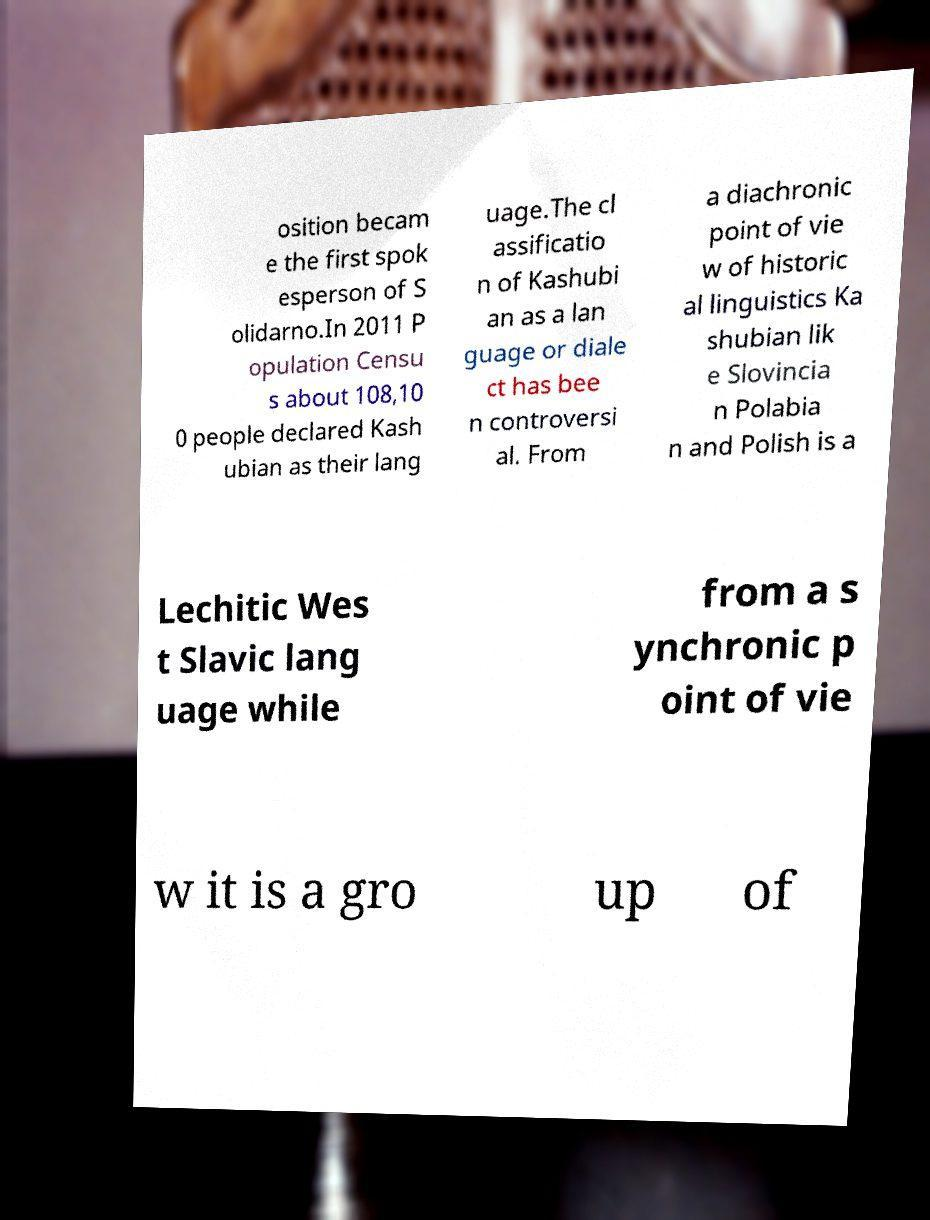Can you accurately transcribe the text from the provided image for me? osition becam e the first spok esperson of S olidarno.In 2011 P opulation Censu s about 108,10 0 people declared Kash ubian as their lang uage.The cl assificatio n of Kashubi an as a lan guage or diale ct has bee n controversi al. From a diachronic point of vie w of historic al linguistics Ka shubian lik e Slovincia n Polabia n and Polish is a Lechitic Wes t Slavic lang uage while from a s ynchronic p oint of vie w it is a gro up of 